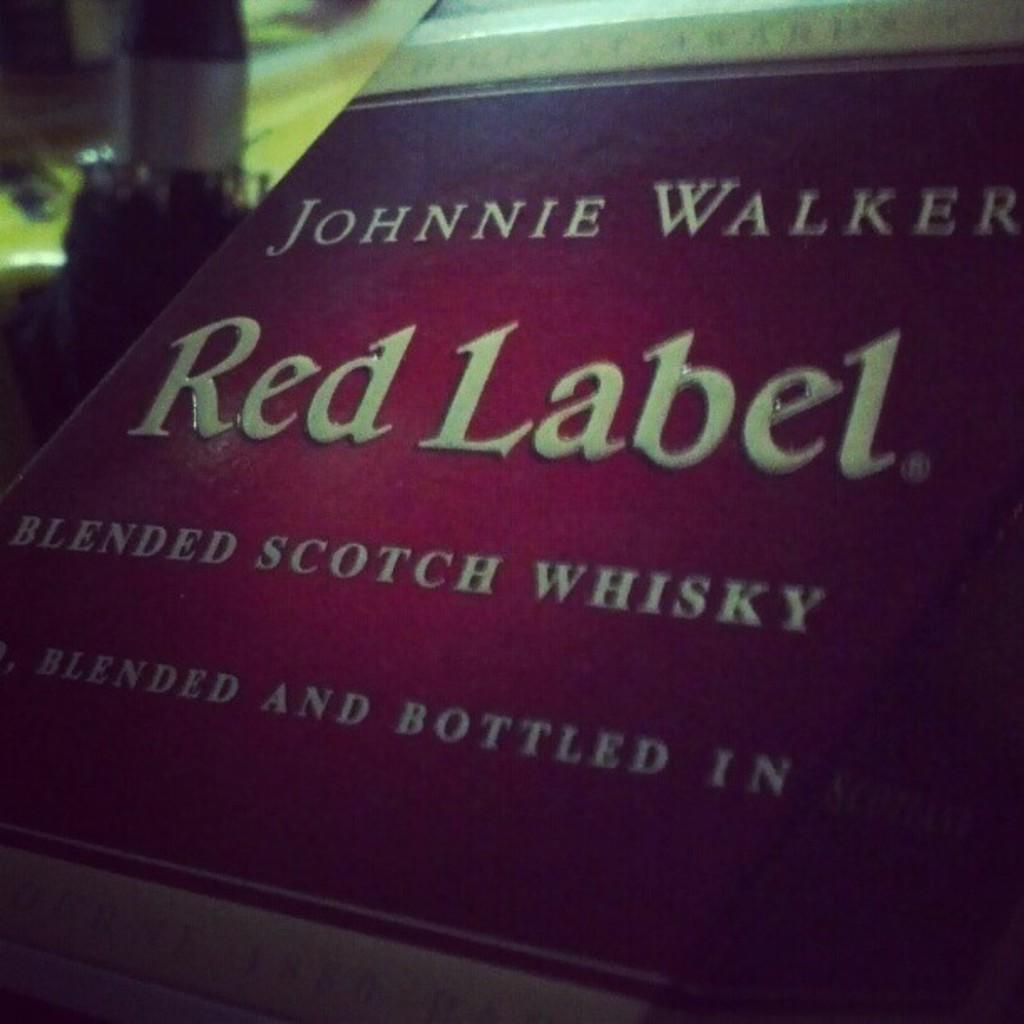<image>
Relay a brief, clear account of the picture shown. A closeup of Johnnie Walker Red Label in a dark room. 